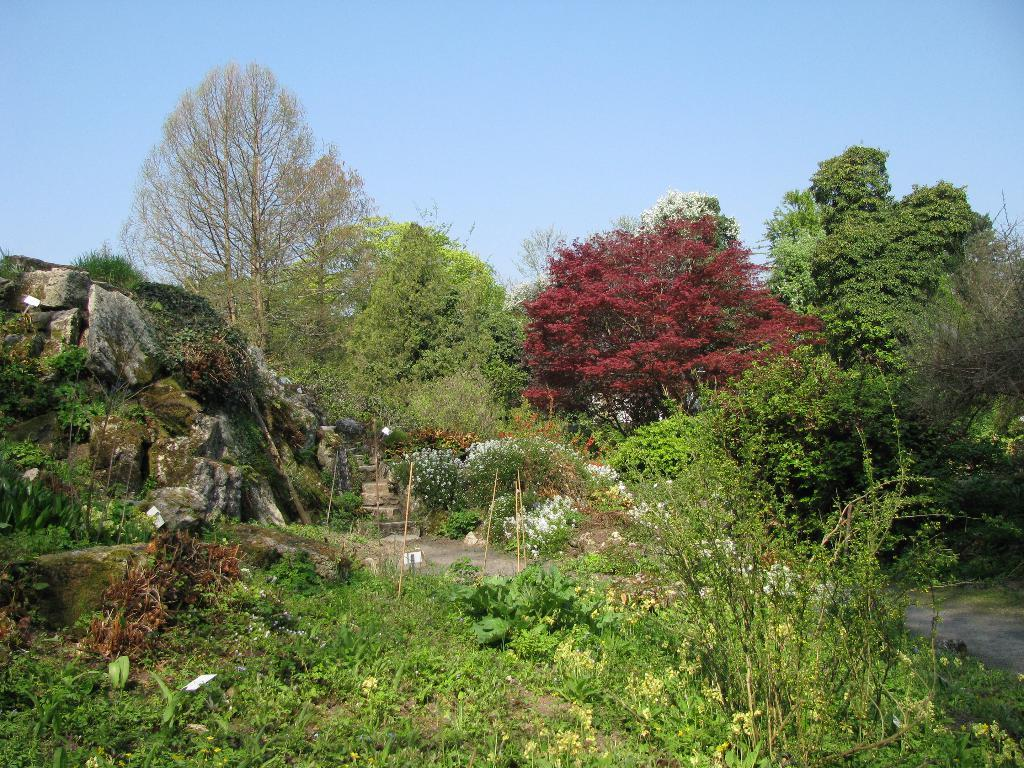What type of natural elements can be seen in the image? There are many trees and plants in the image. Can you describe any man-made structures in the image? Yes, there is a rock and steps visible in the image. What is the condition of the sky in the image? The sky is clear in the image. Is there a designated route for walking or hiking in the image? Yes, there is a path in the image. Where are the ducks swimming in the image? There are no ducks present in the image. What type of fuel is being mined in the image? There is no mining or fuel extraction depicted in the image. 